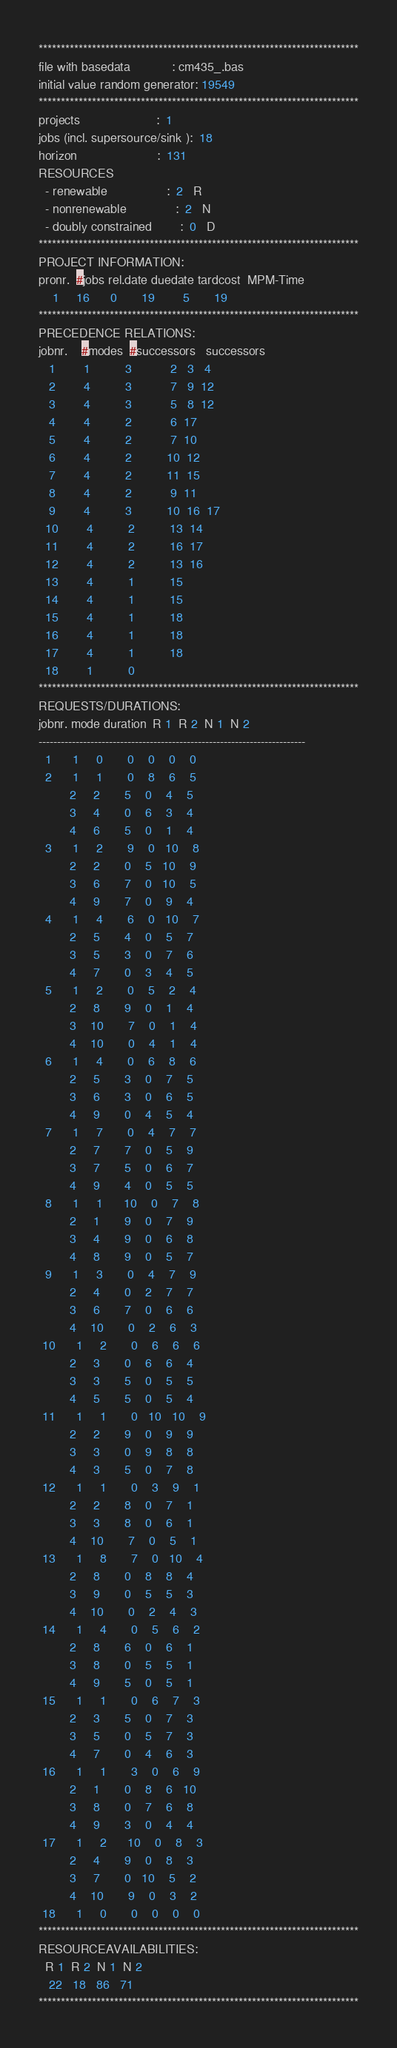<code> <loc_0><loc_0><loc_500><loc_500><_ObjectiveC_>************************************************************************
file with basedata            : cm435_.bas
initial value random generator: 19549
************************************************************************
projects                      :  1
jobs (incl. supersource/sink ):  18
horizon                       :  131
RESOURCES
  - renewable                 :  2   R
  - nonrenewable              :  2   N
  - doubly constrained        :  0   D
************************************************************************
PROJECT INFORMATION:
pronr.  #jobs rel.date duedate tardcost  MPM-Time
    1     16      0       19        5       19
************************************************************************
PRECEDENCE RELATIONS:
jobnr.    #modes  #successors   successors
   1        1          3           2   3   4
   2        4          3           7   9  12
   3        4          3           5   8  12
   4        4          2           6  17
   5        4          2           7  10
   6        4          2          10  12
   7        4          2          11  15
   8        4          2           9  11
   9        4          3          10  16  17
  10        4          2          13  14
  11        4          2          16  17
  12        4          2          13  16
  13        4          1          15
  14        4          1          15
  15        4          1          18
  16        4          1          18
  17        4          1          18
  18        1          0        
************************************************************************
REQUESTS/DURATIONS:
jobnr. mode duration  R 1  R 2  N 1  N 2
------------------------------------------------------------------------
  1      1     0       0    0    0    0
  2      1     1       0    8    6    5
         2     2       5    0    4    5
         3     4       0    6    3    4
         4     6       5    0    1    4
  3      1     2       9    0   10    8
         2     2       0    5   10    9
         3     6       7    0   10    5
         4     9       7    0    9    4
  4      1     4       6    0   10    7
         2     5       4    0    5    7
         3     5       3    0    7    6
         4     7       0    3    4    5
  5      1     2       0    5    2    4
         2     8       9    0    1    4
         3    10       7    0    1    4
         4    10       0    4    1    4
  6      1     4       0    6    8    6
         2     5       3    0    7    5
         3     6       3    0    6    5
         4     9       0    4    5    4
  7      1     7       0    4    7    7
         2     7       7    0    5    9
         3     7       5    0    6    7
         4     9       4    0    5    5
  8      1     1      10    0    7    8
         2     1       9    0    7    9
         3     4       9    0    6    8
         4     8       9    0    5    7
  9      1     3       0    4    7    9
         2     4       0    2    7    7
         3     6       7    0    6    6
         4    10       0    2    6    3
 10      1     2       0    6    6    6
         2     3       0    6    6    4
         3     3       5    0    5    5
         4     5       5    0    5    4
 11      1     1       0   10   10    9
         2     2       9    0    9    9
         3     3       0    9    8    8
         4     3       5    0    7    8
 12      1     1       0    3    9    1
         2     2       8    0    7    1
         3     3       8    0    6    1
         4    10       7    0    5    1
 13      1     8       7    0   10    4
         2     8       0    8    8    4
         3     9       0    5    5    3
         4    10       0    2    4    3
 14      1     4       0    5    6    2
         2     8       6    0    6    1
         3     8       0    5    5    1
         4     9       5    0    5    1
 15      1     1       0    6    7    3
         2     3       5    0    7    3
         3     5       0    5    7    3
         4     7       0    4    6    3
 16      1     1       3    0    6    9
         2     1       0    8    6   10
         3     8       0    7    6    8
         4     9       3    0    4    4
 17      1     2      10    0    8    3
         2     4       9    0    8    3
         3     7       0   10    5    2
         4    10       9    0    3    2
 18      1     0       0    0    0    0
************************************************************************
RESOURCEAVAILABILITIES:
  R 1  R 2  N 1  N 2
   22   18   86   71
************************************************************************
</code> 